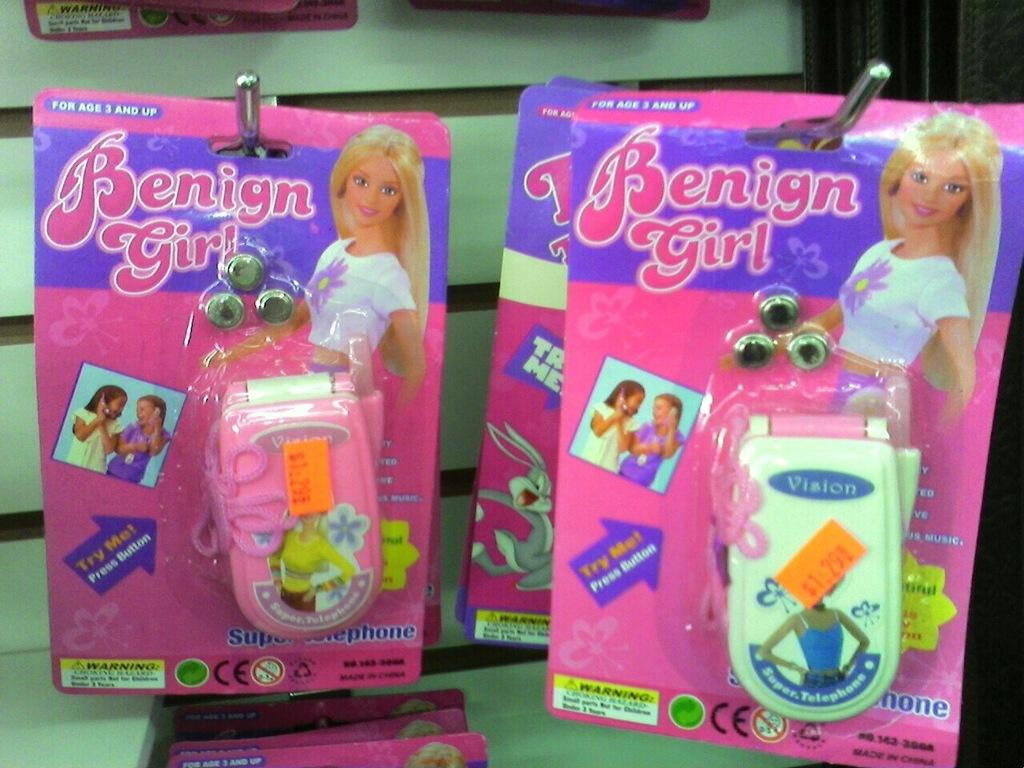What objects are in the foreground of the image? There are toy mobile phone pockets in the foreground of the image. How are the toy mobile phone pockets positioned? The toy mobile phone pockets are hanging from a hook. What can be seen in the background of the image? There is a wall visible in the background of the image. What type of stick is being used in the war depicted in the image? There is no depiction of a war or any stick in the image; it features toy mobile phone pockets hanging from a hook with a wall in the background. 